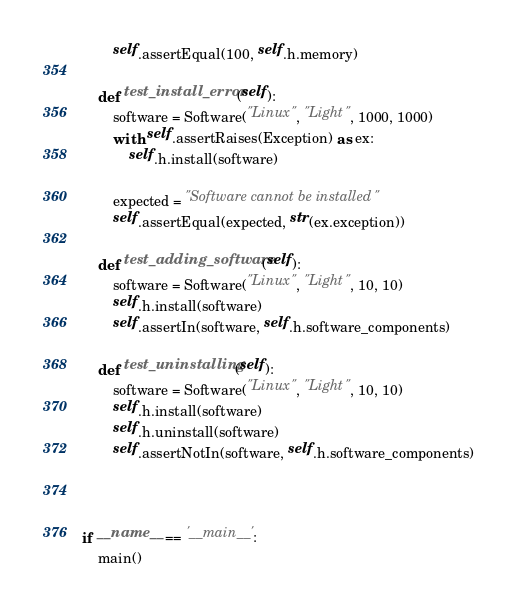<code> <loc_0><loc_0><loc_500><loc_500><_Python_>        self.assertEqual(100, self.h.memory)

    def test_install_error(self):
        software = Software("Linux", "Light", 1000, 1000)
        with self.assertRaises(Exception) as ex:
            self.h.install(software)

        expected = "Software cannot be installed"
        self.assertEqual(expected, str(ex.exception))

    def test_adding_software(self):
        software = Software("Linux", "Light", 10, 10)
        self.h.install(software)
        self.assertIn(software, self.h.software_components)

    def test_uninstalling(self):
        software = Software("Linux", "Light", 10, 10)
        self.h.install(software)
        self.h.uninstall(software)
        self.assertNotIn(software, self.h.software_components)
    


if __name__ == '__main__':
    main()</code> 